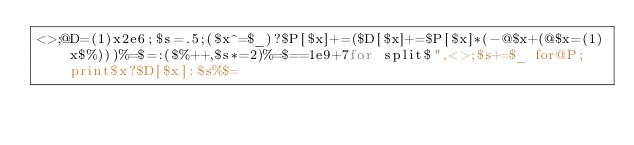<code> <loc_0><loc_0><loc_500><loc_500><_Perl_><>;@D=(1)x2e6;$s=.5;($x^=$_)?$P[$x]+=($D[$x]+=$P[$x]*(-@$x+(@$x=(1)x$%)))%=$=:($%++,$s*=2)%=$==1e9+7for split$",<>;$s+=$_ for@P;print$x?$D[$x]:$s%$=</code> 